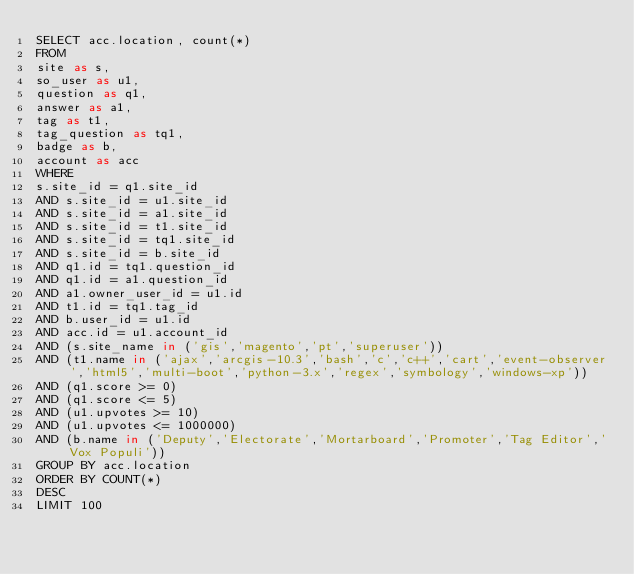Convert code to text. <code><loc_0><loc_0><loc_500><loc_500><_SQL_>SELECT acc.location, count(*)
FROM
site as s,
so_user as u1,
question as q1,
answer as a1,
tag as t1,
tag_question as tq1,
badge as b,
account as acc
WHERE
s.site_id = q1.site_id
AND s.site_id = u1.site_id
AND s.site_id = a1.site_id
AND s.site_id = t1.site_id
AND s.site_id = tq1.site_id
AND s.site_id = b.site_id
AND q1.id = tq1.question_id
AND q1.id = a1.question_id
AND a1.owner_user_id = u1.id
AND t1.id = tq1.tag_id
AND b.user_id = u1.id
AND acc.id = u1.account_id
AND (s.site_name in ('gis','magento','pt','superuser'))
AND (t1.name in ('ajax','arcgis-10.3','bash','c','c++','cart','event-observer','html5','multi-boot','python-3.x','regex','symbology','windows-xp'))
AND (q1.score >= 0)
AND (q1.score <= 5)
AND (u1.upvotes >= 10)
AND (u1.upvotes <= 1000000)
AND (b.name in ('Deputy','Electorate','Mortarboard','Promoter','Tag Editor','Vox Populi'))
GROUP BY acc.location
ORDER BY COUNT(*)
DESC
LIMIT 100
</code> 